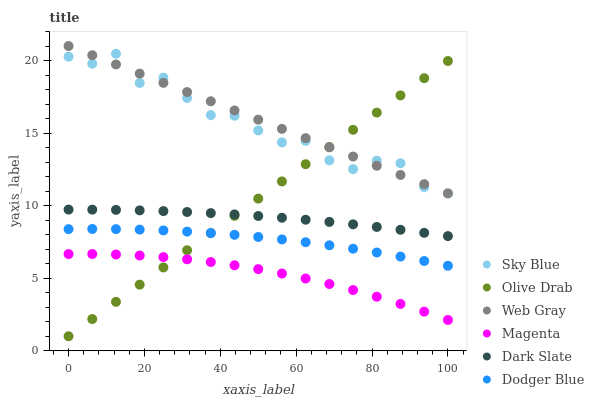Does Magenta have the minimum area under the curve?
Answer yes or no. Yes. Does Web Gray have the maximum area under the curve?
Answer yes or no. Yes. Does Dark Slate have the minimum area under the curve?
Answer yes or no. No. Does Dark Slate have the maximum area under the curve?
Answer yes or no. No. Is Olive Drab the smoothest?
Answer yes or no. Yes. Is Sky Blue the roughest?
Answer yes or no. Yes. Is Dark Slate the smoothest?
Answer yes or no. No. Is Dark Slate the roughest?
Answer yes or no. No. Does Olive Drab have the lowest value?
Answer yes or no. Yes. Does Dark Slate have the lowest value?
Answer yes or no. No. Does Web Gray have the highest value?
Answer yes or no. Yes. Does Dark Slate have the highest value?
Answer yes or no. No. Is Dark Slate less than Sky Blue?
Answer yes or no. Yes. Is Dark Slate greater than Dodger Blue?
Answer yes or no. Yes. Does Olive Drab intersect Web Gray?
Answer yes or no. Yes. Is Olive Drab less than Web Gray?
Answer yes or no. No. Is Olive Drab greater than Web Gray?
Answer yes or no. No. Does Dark Slate intersect Sky Blue?
Answer yes or no. No. 